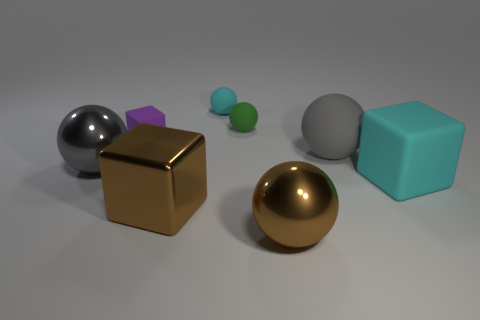There is a thing that is the same color as the big rubber ball; what shape is it?
Provide a succinct answer. Sphere. Is there any other thing that is made of the same material as the small purple thing?
Offer a terse response. Yes. Is the material of the small cyan object the same as the large brown ball?
Keep it short and to the point. No. There is a cyan thing on the right side of the big sphere in front of the large metallic sphere that is behind the cyan cube; what is its shape?
Keep it short and to the point. Cube. Are there fewer green spheres that are on the right side of the tiny green ball than big things that are to the left of the big brown metallic cube?
Provide a succinct answer. Yes. What shape is the big gray object that is to the left of the big shiny thing in front of the large brown metal block?
Keep it short and to the point. Sphere. Is there any other thing that is the same color as the tiny cube?
Provide a succinct answer. No. How many yellow things are either large objects or big metallic blocks?
Offer a terse response. 0. Are there fewer gray things behind the large brown sphere than big objects?
Provide a short and direct response. Yes. There is a big thing to the left of the small purple rubber cube; how many tiny cyan spheres are on the left side of it?
Your answer should be very brief. 0. 